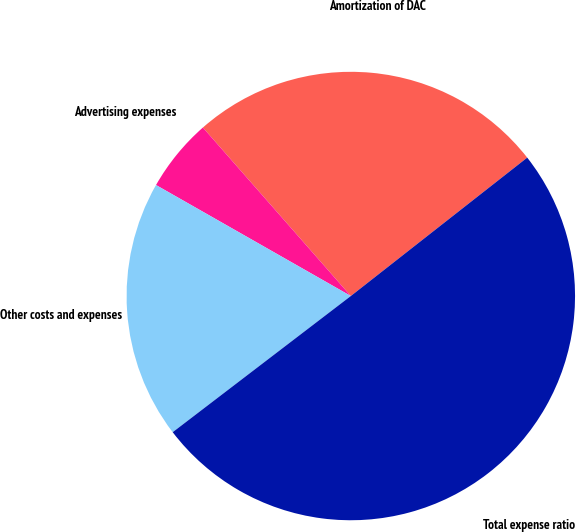<chart> <loc_0><loc_0><loc_500><loc_500><pie_chart><fcel>Amortization of DAC<fcel>Advertising expenses<fcel>Other costs and expenses<fcel>Total expense ratio<nl><fcel>25.88%<fcel>5.29%<fcel>18.63%<fcel>50.2%<nl></chart> 